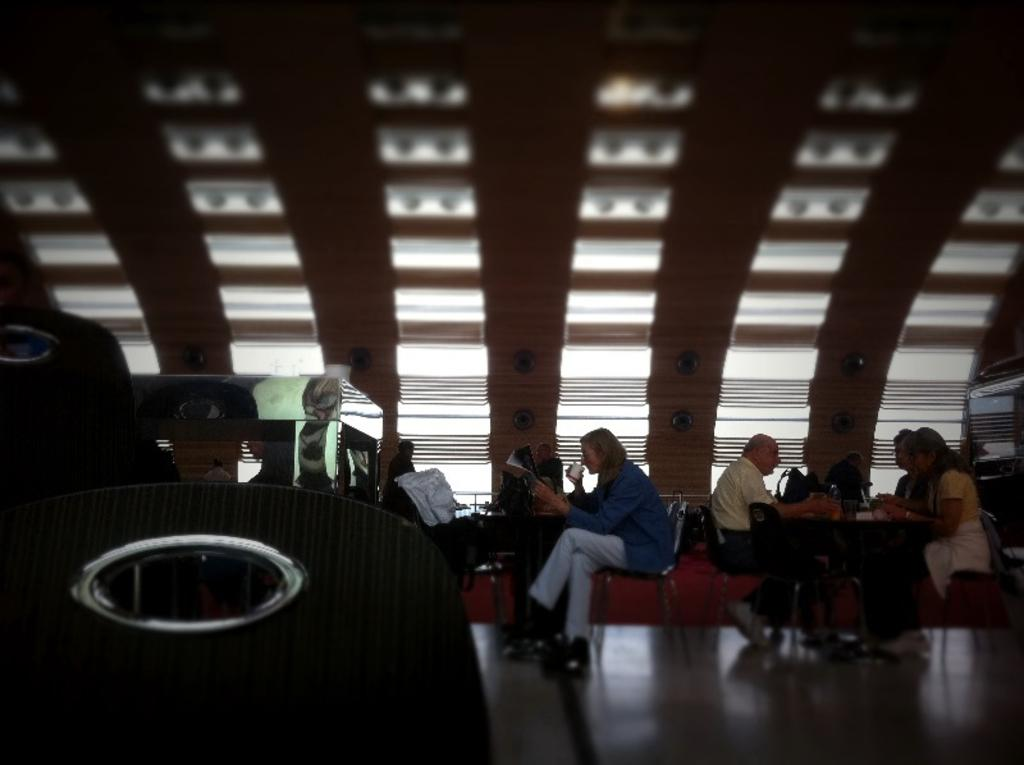What is located in the center of the image? There are tables in the center of the image. What are the people in the image doing? There are persons sitting on chairs in the image. What items can be seen on the tables? Handbags are present on the tables. What can be seen in the background of the image? There are lights and a wall in the background of the image. What type of flesh can be seen on the person's elbow in the image? There is no flesh or elbow visible in the image; it only shows tables, chairs, handbags, lights, and a wall. Is there any eggnog being served in the image? There is no mention of eggnog or any beverages in the image; it only shows tables, chairs, handbags, lights, and a wall. 